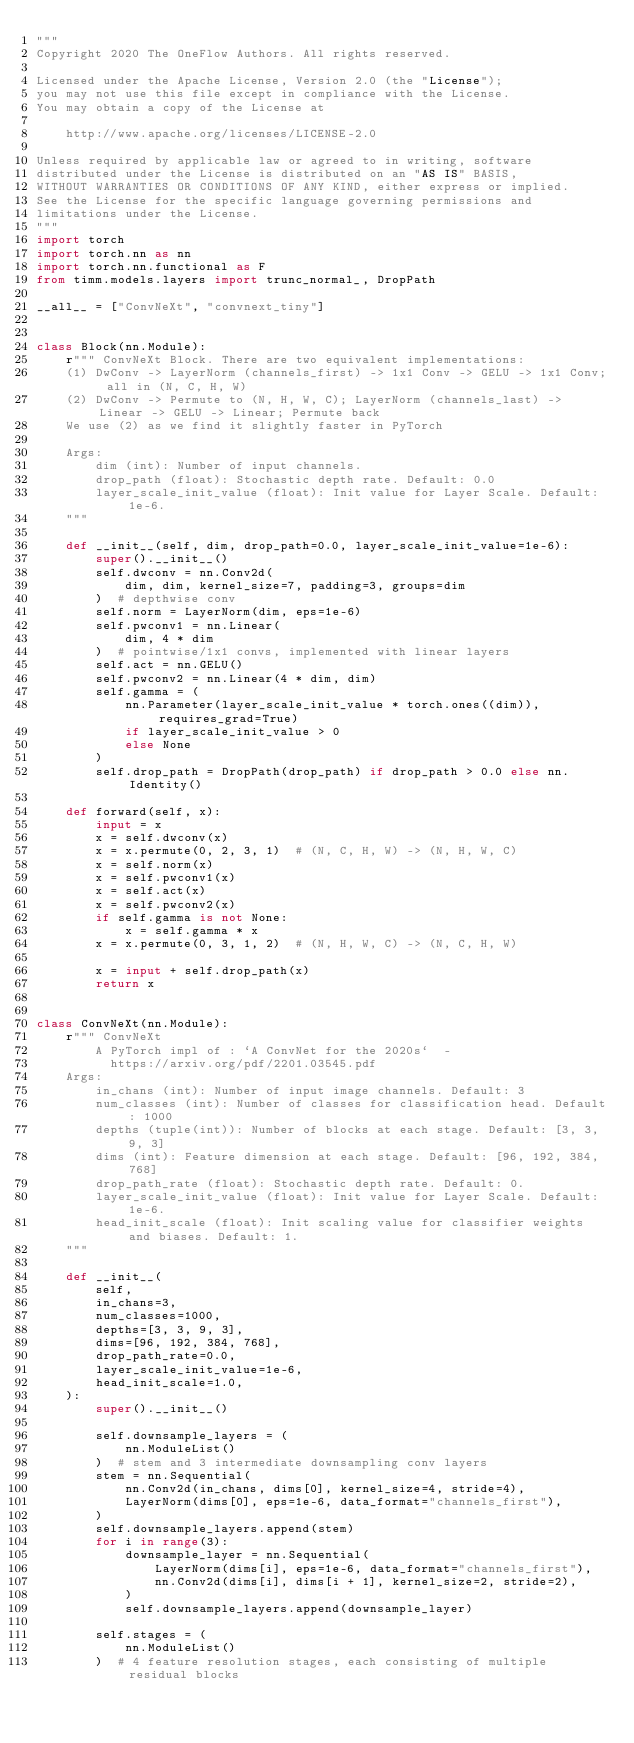Convert code to text. <code><loc_0><loc_0><loc_500><loc_500><_Python_>"""
Copyright 2020 The OneFlow Authors. All rights reserved.

Licensed under the Apache License, Version 2.0 (the "License");
you may not use this file except in compliance with the License.
You may obtain a copy of the License at

    http://www.apache.org/licenses/LICENSE-2.0

Unless required by applicable law or agreed to in writing, software
distributed under the License is distributed on an "AS IS" BASIS,
WITHOUT WARRANTIES OR CONDITIONS OF ANY KIND, either express or implied.
See the License for the specific language governing permissions and
limitations under the License.
"""
import torch
import torch.nn as nn
import torch.nn.functional as F
from timm.models.layers import trunc_normal_, DropPath

__all__ = ["ConvNeXt", "convnext_tiny"]


class Block(nn.Module):
    r""" ConvNeXt Block. There are two equivalent implementations:
    (1) DwConv -> LayerNorm (channels_first) -> 1x1 Conv -> GELU -> 1x1 Conv; all in (N, C, H, W)
    (2) DwConv -> Permute to (N, H, W, C); LayerNorm (channels_last) -> Linear -> GELU -> Linear; Permute back
    We use (2) as we find it slightly faster in PyTorch
    
    Args:
        dim (int): Number of input channels.
        drop_path (float): Stochastic depth rate. Default: 0.0
        layer_scale_init_value (float): Init value for Layer Scale. Default: 1e-6.
    """

    def __init__(self, dim, drop_path=0.0, layer_scale_init_value=1e-6):
        super().__init__()
        self.dwconv = nn.Conv2d(
            dim, dim, kernel_size=7, padding=3, groups=dim
        )  # depthwise conv
        self.norm = LayerNorm(dim, eps=1e-6)
        self.pwconv1 = nn.Linear(
            dim, 4 * dim
        )  # pointwise/1x1 convs, implemented with linear layers
        self.act = nn.GELU()
        self.pwconv2 = nn.Linear(4 * dim, dim)
        self.gamma = (
            nn.Parameter(layer_scale_init_value * torch.ones((dim)), requires_grad=True)
            if layer_scale_init_value > 0
            else None
        )
        self.drop_path = DropPath(drop_path) if drop_path > 0.0 else nn.Identity()

    def forward(self, x):
        input = x
        x = self.dwconv(x)
        x = x.permute(0, 2, 3, 1)  # (N, C, H, W) -> (N, H, W, C)
        x = self.norm(x)
        x = self.pwconv1(x)
        x = self.act(x)
        x = self.pwconv2(x)
        if self.gamma is not None:
            x = self.gamma * x
        x = x.permute(0, 3, 1, 2)  # (N, H, W, C) -> (N, C, H, W)

        x = input + self.drop_path(x)
        return x


class ConvNeXt(nn.Module):
    r""" ConvNeXt
        A PyTorch impl of : `A ConvNet for the 2020s`  -
          https://arxiv.org/pdf/2201.03545.pdf
    Args:
        in_chans (int): Number of input image channels. Default: 3
        num_classes (int): Number of classes for classification head. Default: 1000
        depths (tuple(int)): Number of blocks at each stage. Default: [3, 3, 9, 3]
        dims (int): Feature dimension at each stage. Default: [96, 192, 384, 768]
        drop_path_rate (float): Stochastic depth rate. Default: 0.
        layer_scale_init_value (float): Init value for Layer Scale. Default: 1e-6.
        head_init_scale (float): Init scaling value for classifier weights and biases. Default: 1.
    """

    def __init__(
        self,
        in_chans=3,
        num_classes=1000,
        depths=[3, 3, 9, 3],
        dims=[96, 192, 384, 768],
        drop_path_rate=0.0,
        layer_scale_init_value=1e-6,
        head_init_scale=1.0,
    ):
        super().__init__()

        self.downsample_layers = (
            nn.ModuleList()
        )  # stem and 3 intermediate downsampling conv layers
        stem = nn.Sequential(
            nn.Conv2d(in_chans, dims[0], kernel_size=4, stride=4),
            LayerNorm(dims[0], eps=1e-6, data_format="channels_first"),
        )
        self.downsample_layers.append(stem)
        for i in range(3):
            downsample_layer = nn.Sequential(
                LayerNorm(dims[i], eps=1e-6, data_format="channels_first"),
                nn.Conv2d(dims[i], dims[i + 1], kernel_size=2, stride=2),
            )
            self.downsample_layers.append(downsample_layer)

        self.stages = (
            nn.ModuleList()
        )  # 4 feature resolution stages, each consisting of multiple residual blocks</code> 